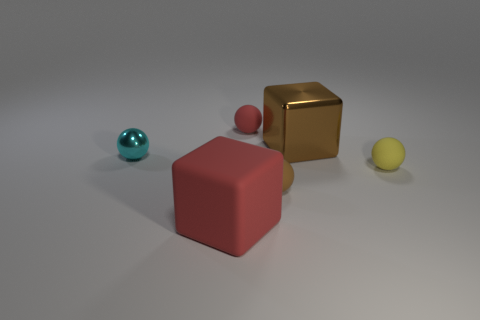Subtract all cyan metal balls. How many balls are left? 3 Subtract all brown spheres. How many spheres are left? 3 Add 4 cyan rubber blocks. How many objects exist? 10 Subtract all blocks. How many objects are left? 4 Subtract 4 spheres. How many spheres are left? 0 Subtract all cyan spheres. Subtract all blue cubes. How many spheres are left? 3 Subtract all purple cylinders. How many blue spheres are left? 0 Subtract all small yellow spheres. Subtract all small yellow spheres. How many objects are left? 4 Add 3 spheres. How many spheres are left? 7 Add 5 big red cubes. How many big red cubes exist? 6 